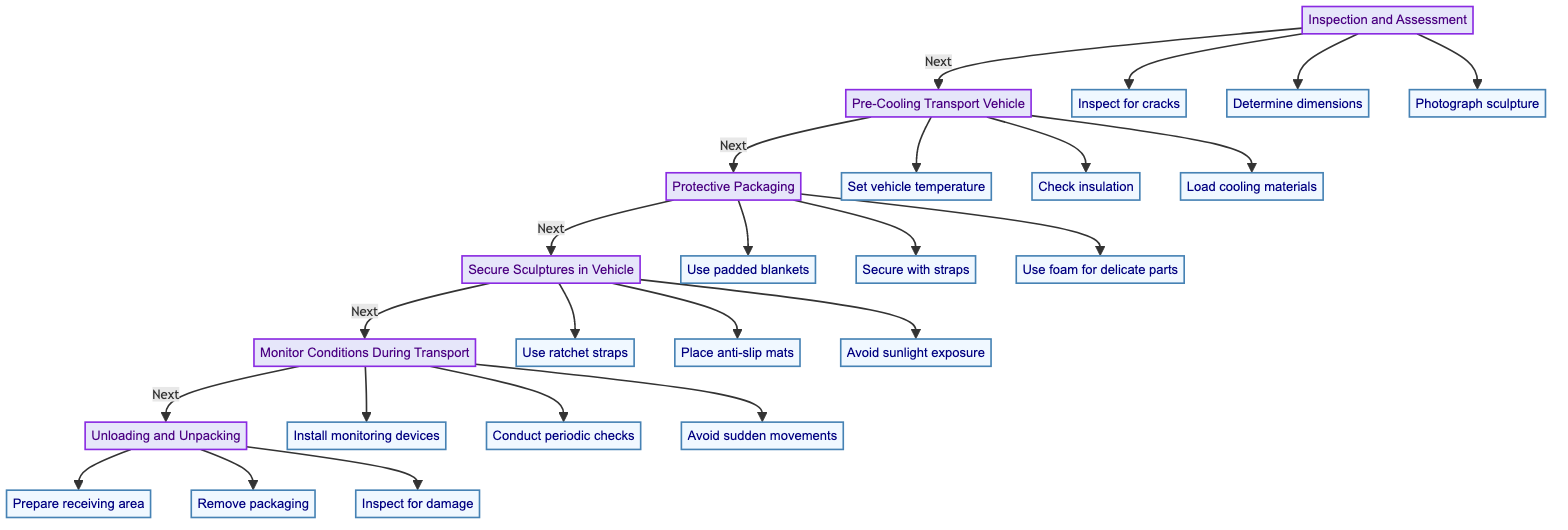What is the first step in the process? The first step according to the diagram is "Inspection and Assessment." It is the initial node that leads to the next step in the protocol.
Answer: Inspection and Assessment How many steps are in the protocol? By counting the main steps in the diagram, there are six distinct steps that outline the process of safe transportation of large ice sculptures.
Answer: Six Which step comes after "Secure Sculptures in Vehicle"? The step that follows "Secure Sculptures in Vehicle" is "Monitor Conditions During Transport," as indicated by the directional flow of the diagram.
Answer: Monitor Conditions During Transport What action is taken during "Protective Packaging"? During "Protective Packaging," the action taken is "Use padded blankets to cover the sculpture," which is one of the three steps involved in this phase.
Answer: Use padded blankets to cover the sculpture Why is temperature important during transportation? Temperature is critical during transportation to maintain the integrity of the ice sculpture, preventing melting or structural damage, as emphasized in several steps throughout the protocol.
Answer: To maintain sculpture integrity How many actions are involved in "Unloading and Unpacking"? There are three specific actions outlined under "Unloading and Unpacking," which include preparing the area, removing the packaging, and inspecting the sculpture for damage.
Answer: Three What type of materials are loaded in the transport vehicle? The materials referenced in the step "Load cooling materials" include dry ice or gel packs, which are specifically mentioned as additional support for temperature control.
Answer: Dry ice or gel packs What is necessary before unloading the sculpture? Before unloading the sculpture, it is necessary to prepare the receiving area by lowering the ambient temperature, as specified in the instructions to ensure safe handling.
Answer: Lower ambient temperature What should be avoided during the transport process? The transport process should avoid sudden stops and sharp turns, which are explicitly stated as precautions to minimize movement and potential damage.
Answer: Sudden stops and sharp turns 